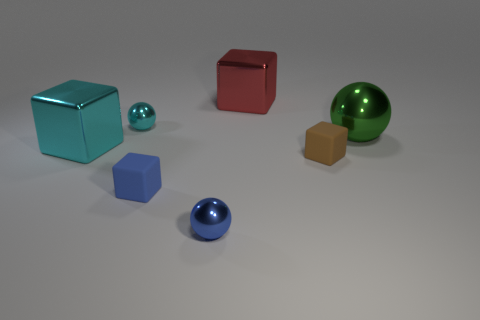Add 1 tiny cyan matte cylinders. How many objects exist? 8 Subtract all spheres. How many objects are left? 4 Subtract 0 brown spheres. How many objects are left? 7 Subtract all brown cubes. Subtract all tiny matte objects. How many objects are left? 4 Add 2 small blue matte things. How many small blue matte things are left? 3 Add 7 small cyan cubes. How many small cyan cubes exist? 7 